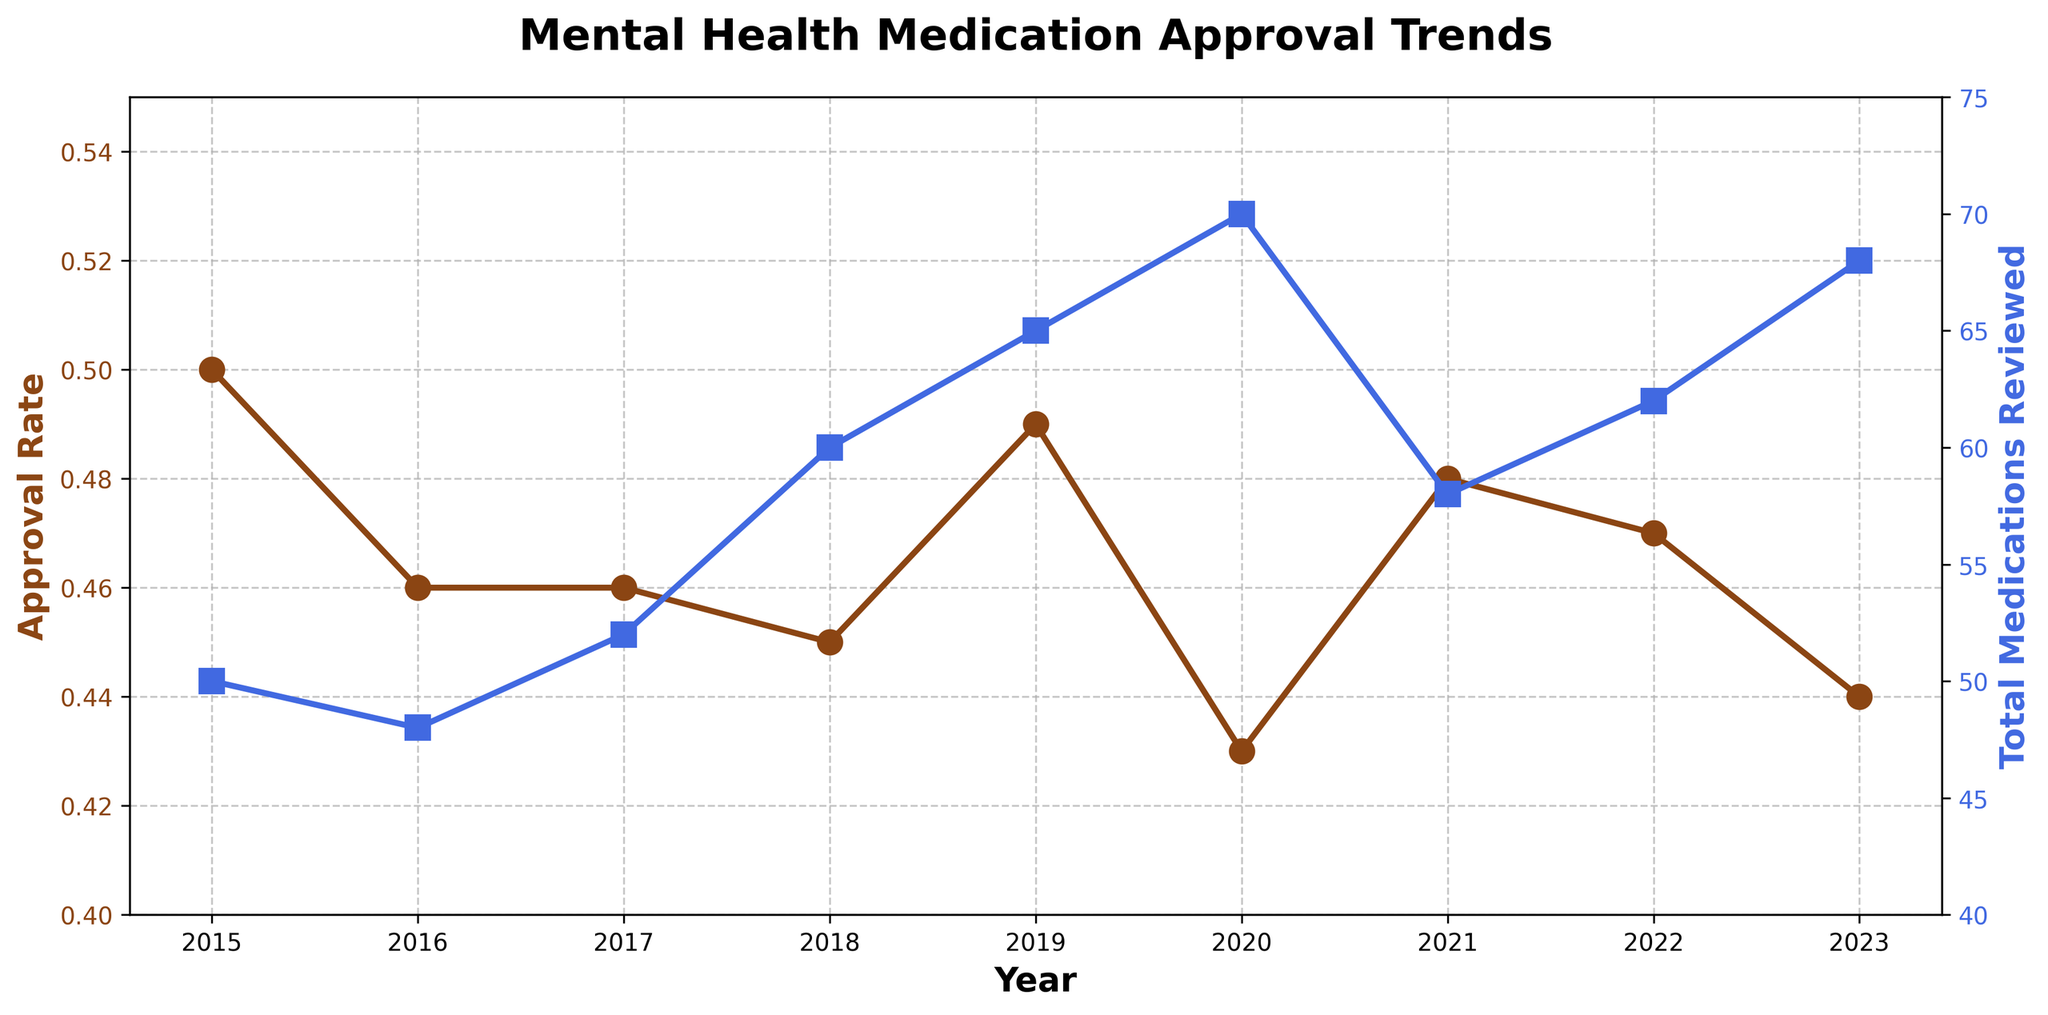What does the title of the figure say? The title is at the top of the figure. It provides a summary of what the figure is about. The title helps viewers to quickly understand the key focus of the figure.
Answer: Mental Health Medication Approval Trends How many ticks are there on the x-axis? You can count the number of tick marks on the x-axis, which represent the years in this time series plot. These ticks correspond to each year the data covers.
Answer: 9 What is the approval rate in 2020? Find the point on the approval rate line that corresponds to the year 2020 and read its value. The approval rate is shown on the left y-axis.
Answer: 0.43 What has been the general trend in the total number of mental health medications reviewed from 2015 to 2023? Look at the line in blue representing the total medications reviewed and examine its direction over time. Observing its slope provides insight into the trend.
Answer: Increasing Which year had the highest number of total mental health medications reviewed? Identify the peak point on the blue line that represents the total medications reviewed and find the corresponding year on the x-axis.
Answer: 2020 Is the approval rate higher in 2019 or 2022? Compare the points on the brown approval rate line for the years 2019 and 2022. Read and compare the values from the left y-axis.
Answer: 2019 What is the average approval rate from 2019 to 2021? Add the approval rates for the years 2019, 2020, and 2021 and then divide by 3 to find the average. Approval rates are: 0.49 (2019), 0.43 (2020), 0.48 (2021). (0.49 + 0.43 + 0.48) / 3 = 1.4 / 3.
Answer: 0.47 How does the approval rate change between 2015 and 2016? Look at the approval rate values for 2015 and 2016. Compare the two values to see if there is an increase, decrease, or no change.
Answer: Decreases Were more mental health medications reviewed in 2017 or in 2018? Compare the values of the total medications reviewed for the years 2017 and 2018 by looking at the positions of the blue squares. The higher value indicates the year with more reviews.
Answer: 2018 